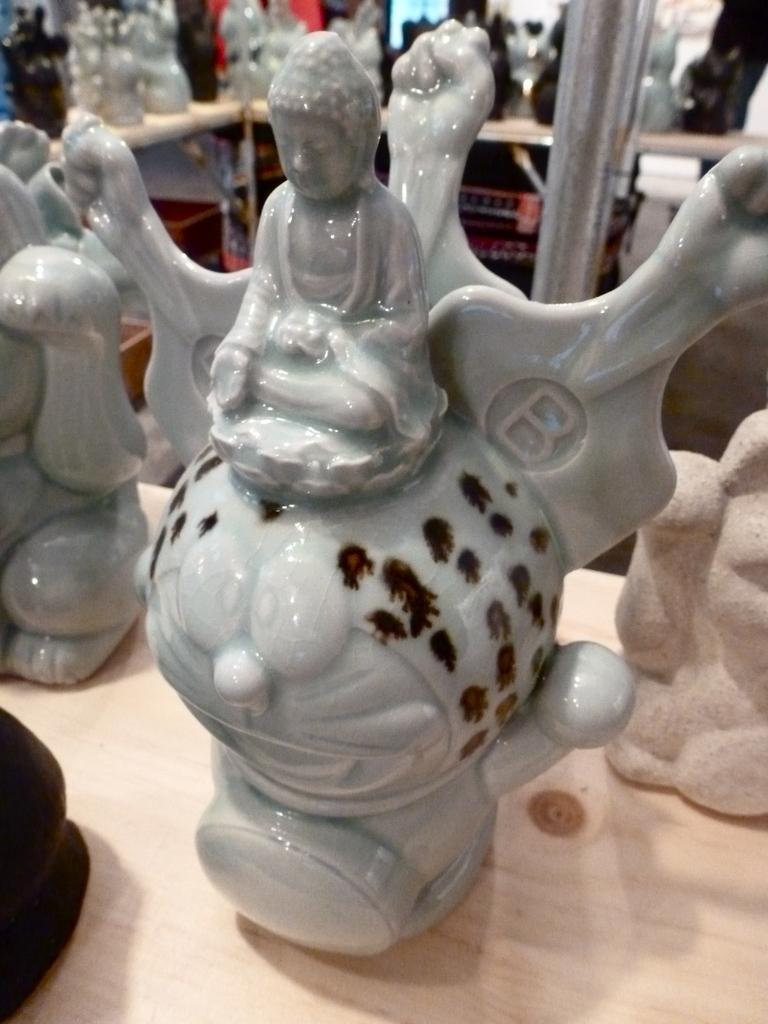What is the main subject of the image? The main subject of the image is toys placed on a table. Where are the toys located on the table? The toys are placed in the center of the table. What can be seen in the background of the image? In the background, toys are arranged in shelves. What type of feather can be seen on the chair in the image? There is no chair present in the image, and therefore no feather can be seen on it. 